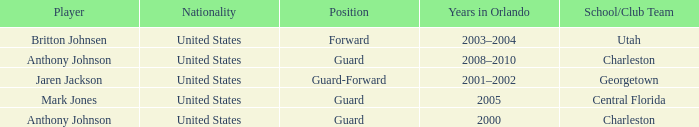Who was the Player that spent the Year 2005 in Orlando? Mark Jones. 